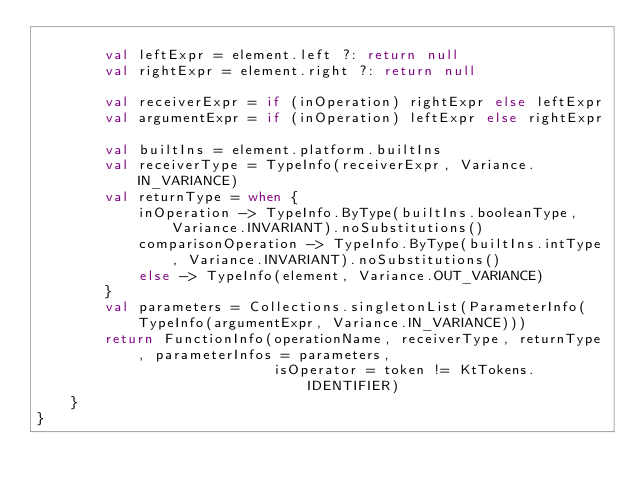Convert code to text. <code><loc_0><loc_0><loc_500><loc_500><_Kotlin_>
        val leftExpr = element.left ?: return null
        val rightExpr = element.right ?: return null

        val receiverExpr = if (inOperation) rightExpr else leftExpr
        val argumentExpr = if (inOperation) leftExpr else rightExpr

        val builtIns = element.platform.builtIns
        val receiverType = TypeInfo(receiverExpr, Variance.IN_VARIANCE)
        val returnType = when {
            inOperation -> TypeInfo.ByType(builtIns.booleanType, Variance.INVARIANT).noSubstitutions()
            comparisonOperation -> TypeInfo.ByType(builtIns.intType, Variance.INVARIANT).noSubstitutions()
            else -> TypeInfo(element, Variance.OUT_VARIANCE)
        }
        val parameters = Collections.singletonList(ParameterInfo(TypeInfo(argumentExpr, Variance.IN_VARIANCE)))
        return FunctionInfo(operationName, receiverType, returnType, parameterInfos = parameters,
                            isOperator = token != KtTokens.IDENTIFIER)
    }
}
</code> 